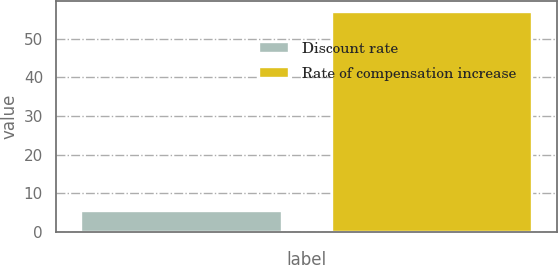Convert chart to OTSL. <chart><loc_0><loc_0><loc_500><loc_500><bar_chart><fcel>Discount rate<fcel>Rate of compensation increase<nl><fcel>5.5<fcel>57<nl></chart> 